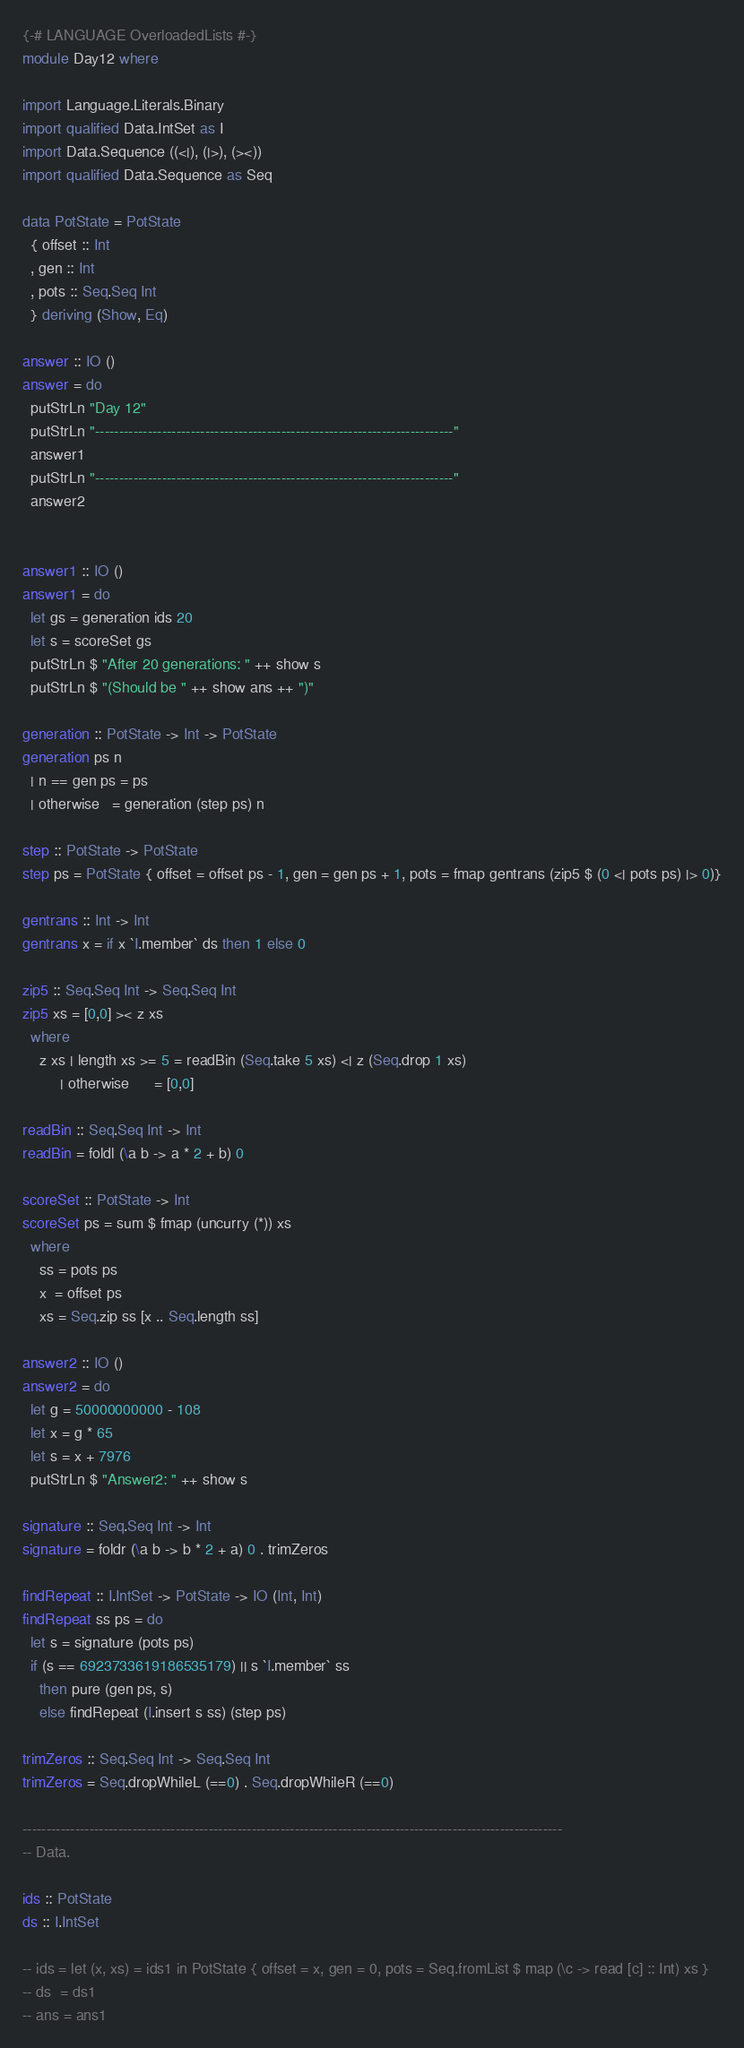Convert code to text. <code><loc_0><loc_0><loc_500><loc_500><_Haskell_>{-# LANGUAGE OverloadedLists #-}
module Day12 where

import Language.Literals.Binary
import qualified Data.IntSet as I
import Data.Sequence ((<|), (|>), (><))
import qualified Data.Sequence as Seq

data PotState = PotState 
  { offset :: Int
  , gen :: Int
  , pots :: Seq.Seq Int
  } deriving (Show, Eq)

answer :: IO ()
answer = do
  putStrLn "Day 12"
  putStrLn "---------------------------------------------------------------------------"
  answer1
  putStrLn "---------------------------------------------------------------------------"
  answer2


answer1 :: IO ()
answer1 = do
  let gs = generation ids 20
  let s = scoreSet gs
  putStrLn $ "After 20 generations: " ++ show s
  putStrLn $ "(Should be " ++ show ans ++ ")"

generation :: PotState -> Int -> PotState
generation ps n 
  | n == gen ps = ps
  | otherwise   = generation (step ps) n

step :: PotState -> PotState
step ps = PotState { offset = offset ps - 1, gen = gen ps + 1, pots = fmap gentrans (zip5 $ (0 <| pots ps) |> 0)}

gentrans :: Int -> Int
gentrans x = if x `I.member` ds then 1 else 0

zip5 :: Seq.Seq Int -> Seq.Seq Int
zip5 xs = [0,0] >< z xs
  where
    z xs | length xs >= 5 = readBin (Seq.take 5 xs) <| z (Seq.drop 1 xs)
         | otherwise      = [0,0]

readBin :: Seq.Seq Int -> Int
readBin = foldl (\a b -> a * 2 + b) 0

scoreSet :: PotState -> Int
scoreSet ps = sum $ fmap (uncurry (*)) xs
  where
    ss = pots ps
    x  = offset ps
    xs = Seq.zip ss [x .. Seq.length ss]

answer2 :: IO ()
answer2 = do
  let g = 50000000000 - 108
  let x = g * 65
  let s = x + 7976
  putStrLn $ "Answer2: " ++ show s

signature :: Seq.Seq Int -> Int
signature = foldr (\a b -> b * 2 + a) 0 . trimZeros

findRepeat :: I.IntSet -> PotState -> IO (Int, Int)
findRepeat ss ps = do
  let s = signature (pots ps)
  if (s == 6923733619186535179) || s `I.member` ss
    then pure (gen ps, s)
    else findRepeat (I.insert s ss) (step ps)

trimZeros :: Seq.Seq Int -> Seq.Seq Int
trimZeros = Seq.dropWhileL (==0) . Seq.dropWhileR (==0)

-----------------------------------------------------------------------------------------------------------------
-- Data.

ids :: PotState
ds :: I.IntSet

-- ids = let (x, xs) = ids1 in PotState { offset = x, gen = 0, pots = Seq.fromList $ map (\c -> read [c] :: Int) xs }
-- ds  = ds1
-- ans = ans1</code> 